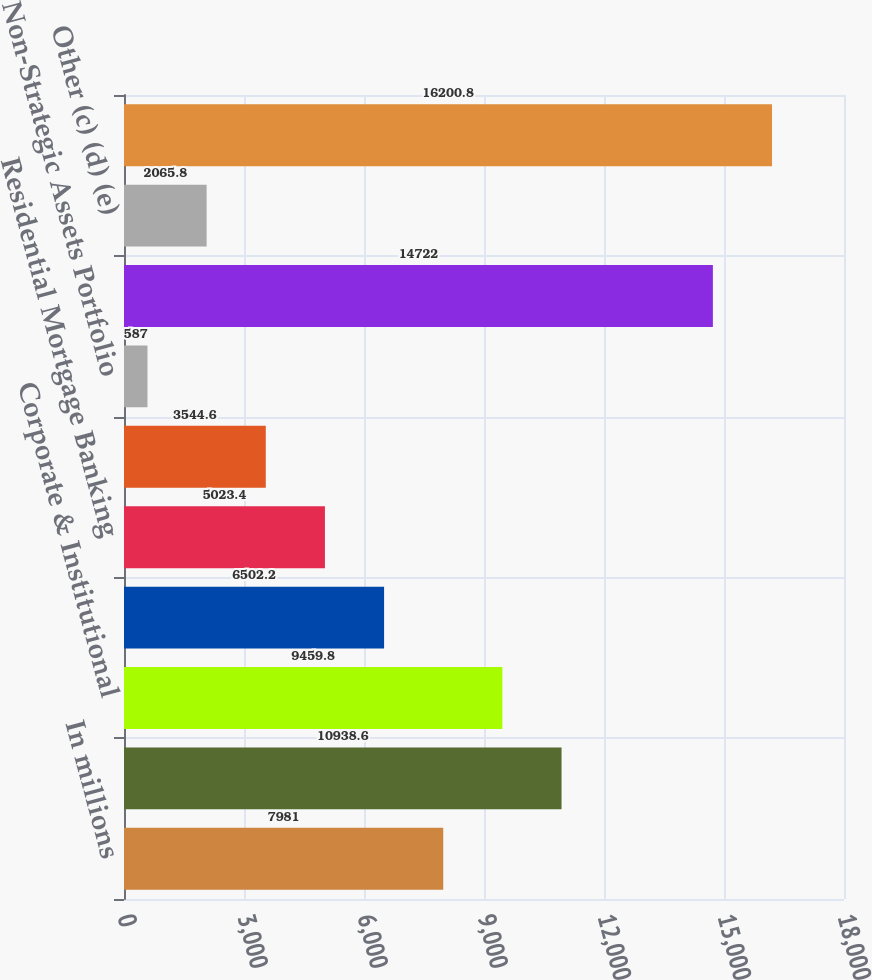Convert chart to OTSL. <chart><loc_0><loc_0><loc_500><loc_500><bar_chart><fcel>In millions<fcel>Retail Banking<fcel>Corporate & Institutional<fcel>Asset Management Group<fcel>Residential Mortgage Banking<fcel>BlackRock<fcel>Non-Strategic Assets Portfolio<fcel>Total business segments<fcel>Other (c) (d) (e)<fcel>Total<nl><fcel>7981<fcel>10938.6<fcel>9459.8<fcel>6502.2<fcel>5023.4<fcel>3544.6<fcel>587<fcel>14722<fcel>2065.8<fcel>16200.8<nl></chart> 